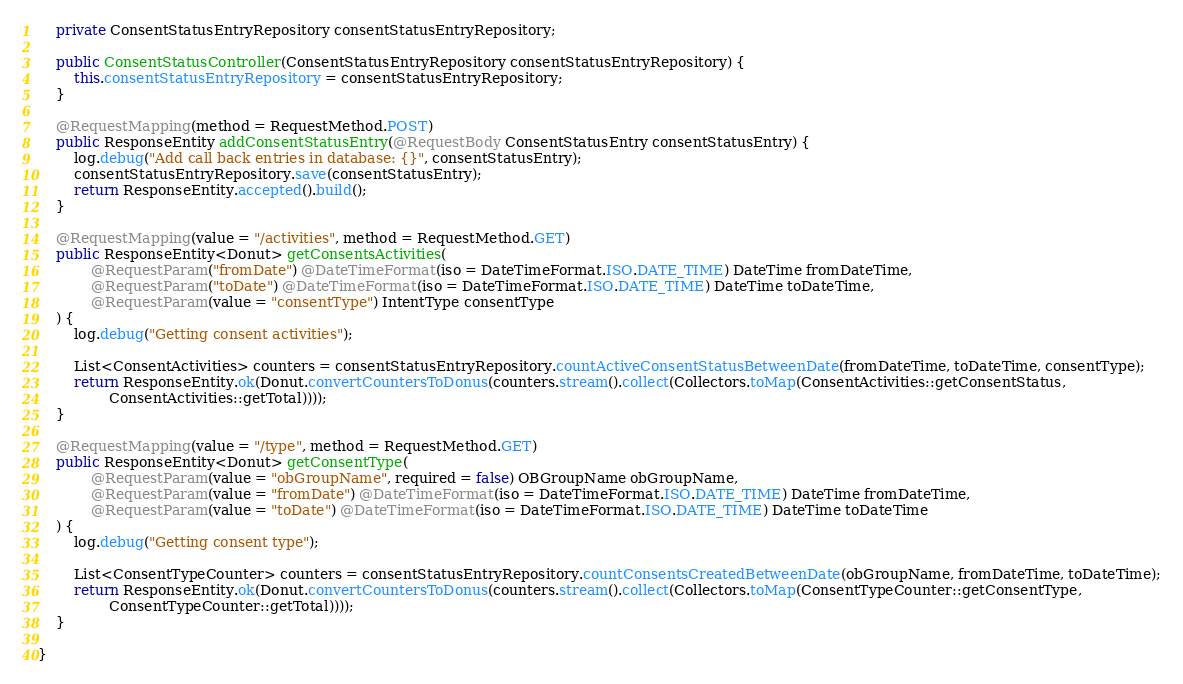<code> <loc_0><loc_0><loc_500><loc_500><_Java_>    private ConsentStatusEntryRepository consentStatusEntryRepository;

    public ConsentStatusController(ConsentStatusEntryRepository consentStatusEntryRepository) {
        this.consentStatusEntryRepository = consentStatusEntryRepository;
    }

    @RequestMapping(method = RequestMethod.POST)
    public ResponseEntity addConsentStatusEntry(@RequestBody ConsentStatusEntry consentStatusEntry) {
        log.debug("Add call back entries in database: {}", consentStatusEntry);
        consentStatusEntryRepository.save(consentStatusEntry);
        return ResponseEntity.accepted().build();
    }

    @RequestMapping(value = "/activities", method = RequestMethod.GET)
    public ResponseEntity<Donut> getConsentsActivities(
            @RequestParam("fromDate") @DateTimeFormat(iso = DateTimeFormat.ISO.DATE_TIME) DateTime fromDateTime,
            @RequestParam("toDate") @DateTimeFormat(iso = DateTimeFormat.ISO.DATE_TIME) DateTime toDateTime,
            @RequestParam(value = "consentType") IntentType consentType
    ) {
        log.debug("Getting consent activities");

        List<ConsentActivities> counters = consentStatusEntryRepository.countActiveConsentStatusBetweenDate(fromDateTime, toDateTime, consentType);
        return ResponseEntity.ok(Donut.convertCountersToDonus(counters.stream().collect(Collectors.toMap(ConsentActivities::getConsentStatus,
                ConsentActivities::getTotal))));
    }

    @RequestMapping(value = "/type", method = RequestMethod.GET)
    public ResponseEntity<Donut> getConsentType(
            @RequestParam(value = "obGroupName", required = false) OBGroupName obGroupName,
            @RequestParam(value = "fromDate") @DateTimeFormat(iso = DateTimeFormat.ISO.DATE_TIME) DateTime fromDateTime,
            @RequestParam(value = "toDate") @DateTimeFormat(iso = DateTimeFormat.ISO.DATE_TIME) DateTime toDateTime
    ) {
        log.debug("Getting consent type");

        List<ConsentTypeCounter> counters = consentStatusEntryRepository.countConsentsCreatedBetweenDate(obGroupName, fromDateTime, toDateTime);
        return ResponseEntity.ok(Donut.convertCountersToDonus(counters.stream().collect(Collectors.toMap(ConsentTypeCounter::getConsentType,
                ConsentTypeCounter::getTotal))));
    }

}
</code> 